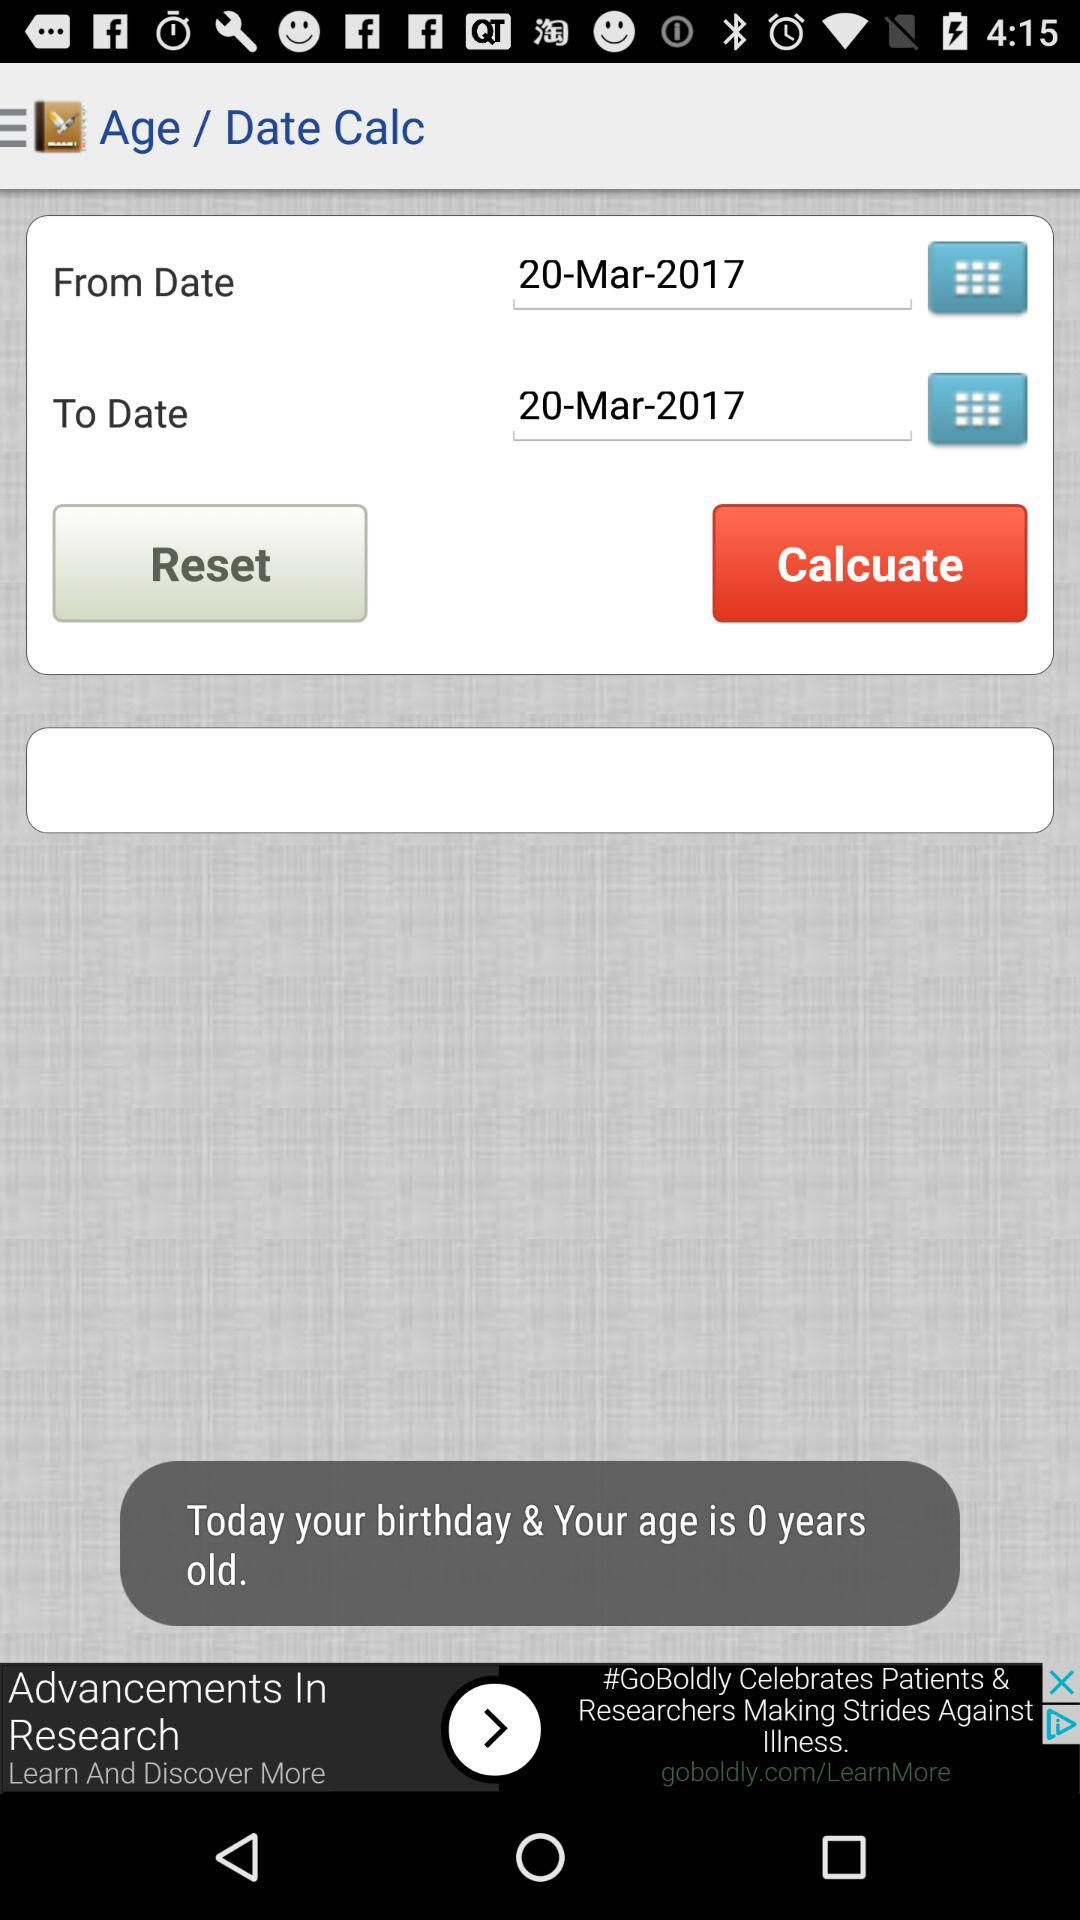What is the estimated age based on the given date? The estimated age is 0 years. 